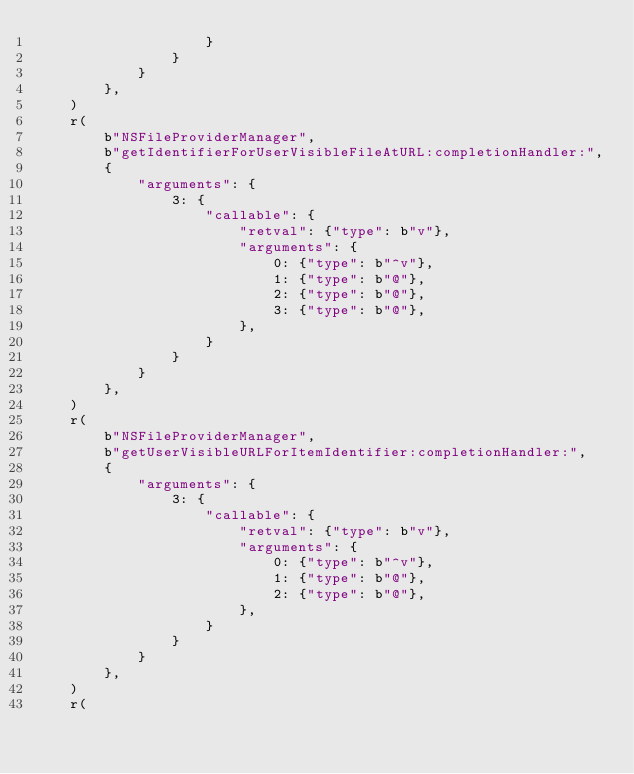<code> <loc_0><loc_0><loc_500><loc_500><_Python_>                    }
                }
            }
        },
    )
    r(
        b"NSFileProviderManager",
        b"getIdentifierForUserVisibleFileAtURL:completionHandler:",
        {
            "arguments": {
                3: {
                    "callable": {
                        "retval": {"type": b"v"},
                        "arguments": {
                            0: {"type": b"^v"},
                            1: {"type": b"@"},
                            2: {"type": b"@"},
                            3: {"type": b"@"},
                        },
                    }
                }
            }
        },
    )
    r(
        b"NSFileProviderManager",
        b"getUserVisibleURLForItemIdentifier:completionHandler:",
        {
            "arguments": {
                3: {
                    "callable": {
                        "retval": {"type": b"v"},
                        "arguments": {
                            0: {"type": b"^v"},
                            1: {"type": b"@"},
                            2: {"type": b"@"},
                        },
                    }
                }
            }
        },
    )
    r(</code> 